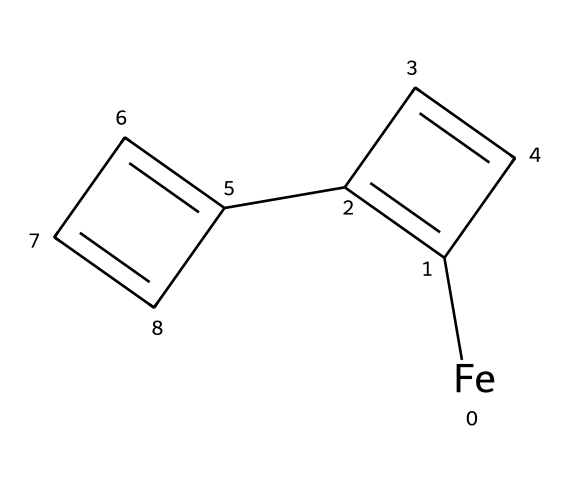how many total carbon atoms are there in the chemical? In the SMILES representation, the "C" represents carbon atoms. There are 10 carbon ("C") symbols visible: 5 from the first ring (C1), and 5 from the second ring (C2).
Answer: 10 what is the oxidation state of iron in this compound? The SMILES notation shows iron ([Fe]) without any additional charges. In ferrocene, iron typically has an oxidation state of +2, as it is sandwiched between two cyclopentadienyl anions.
Answer: +2 how many aromatic rings are present in ferrocene? The chemical structure indicates two distinct rings, both of which are cyclopentadiene rings that are aromatic in character due to their conjugated pi system.
Answer: 2 what type of bonding is predominantly found in ferrocene? Ferrocene features the interaction of metal and organic ligands through pi-backbonding, which is characteristic of organometallic compounds.
Answer: pi-backbonding which metals are commonly found in organometallic compounds like ferrocene? Organometallic compounds encompass a variety of metals, but ferrocene specifically contains iron as the central metal atom, typical for this class.
Answer: iron how are the carbon rings in ferrocene connected to iron? The cyclopentadiene anions in ferrocene coordinate to the iron center through their pi electrons, illustrating a typical structure in organometallic chemistry.
Answer: through pi electrons what is the primary visual color associated with ferrocene? Ferrocene is known for its distinctive vibrant orange coloration, which is often used in artist pigments.
Answer: vibrant orange 